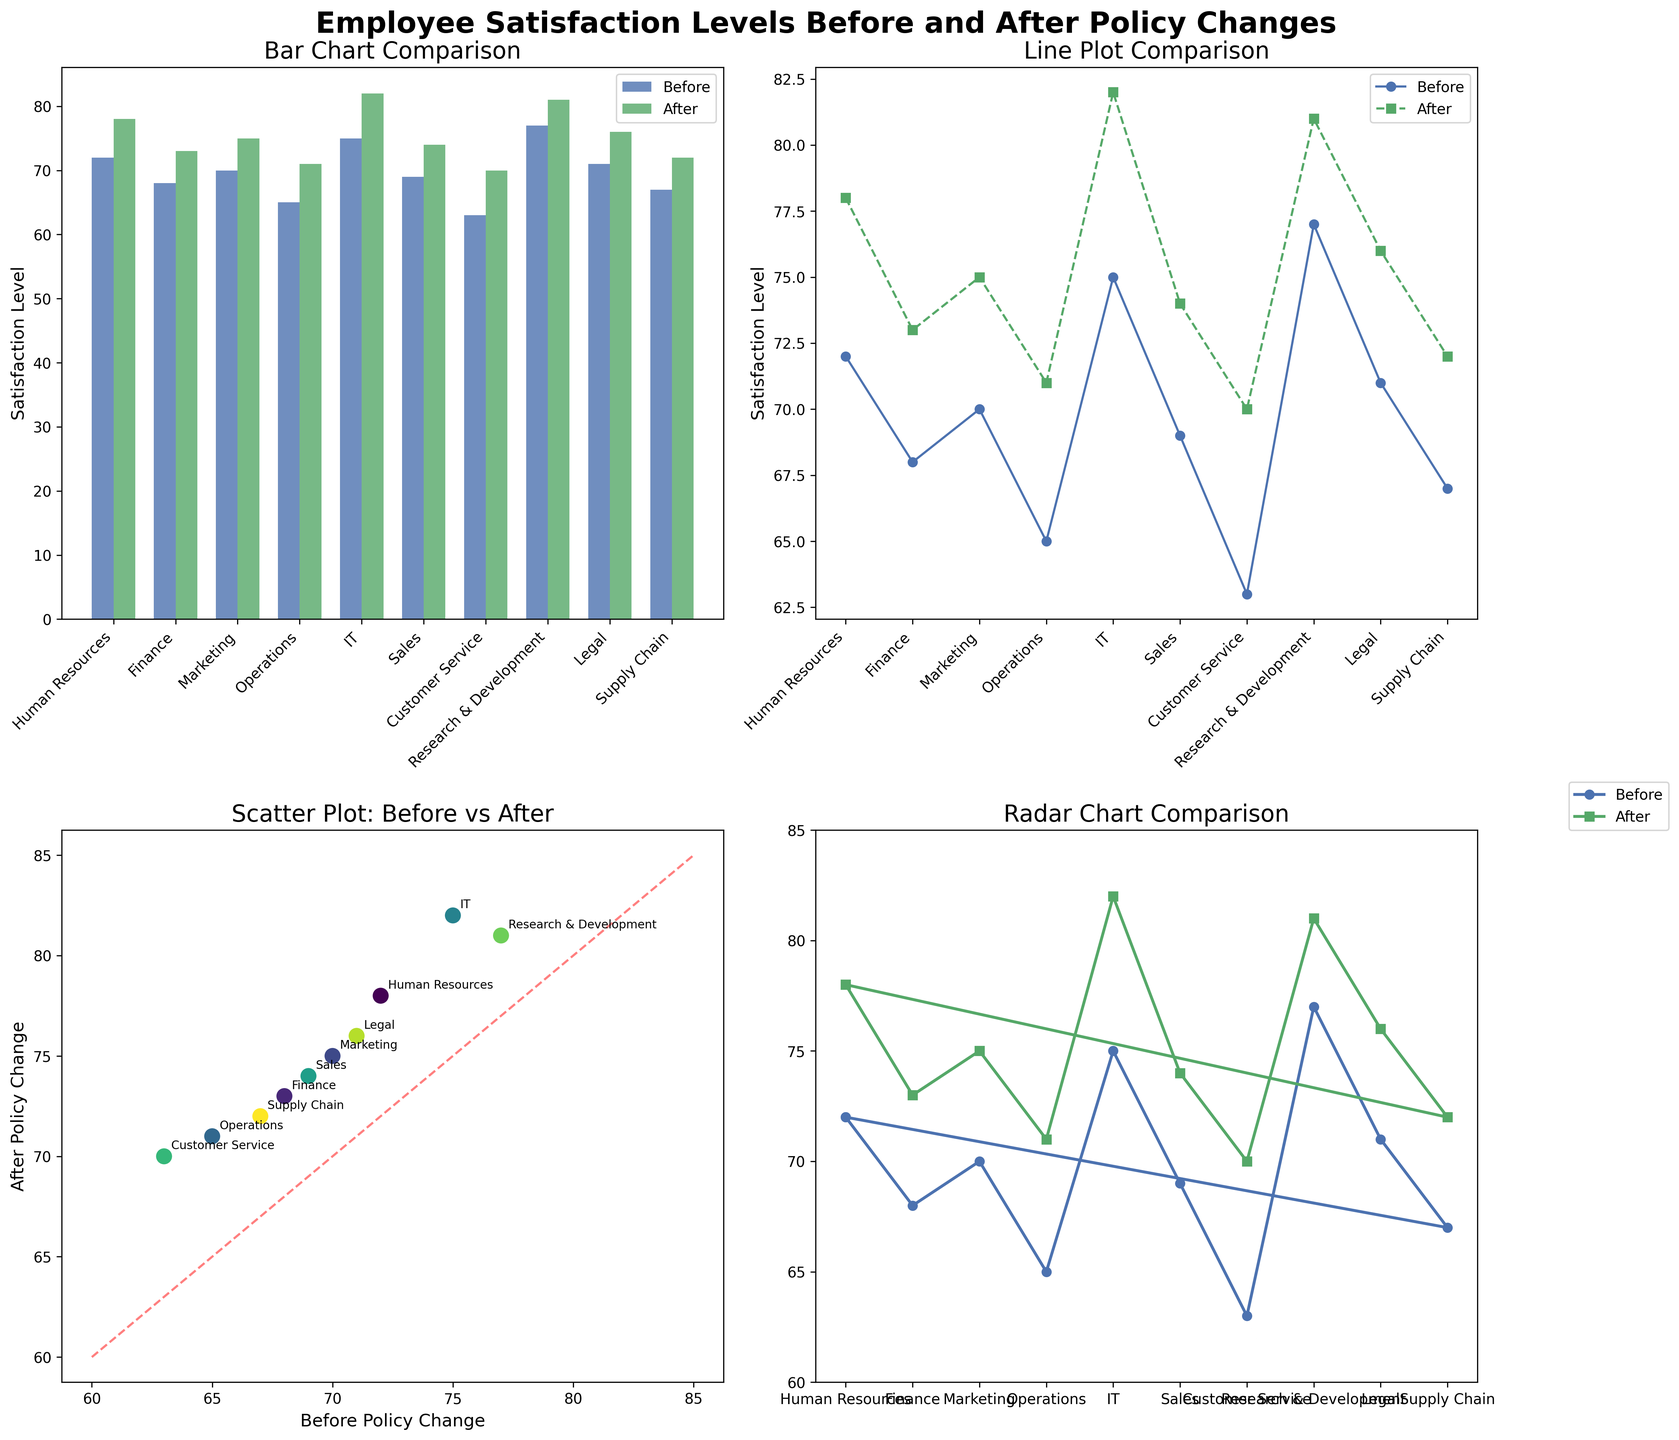What is the title of the entire figure? The title of the entire figure is positioned at the top and should summarize what the figure is about. It reads, "Employee Satisfaction Levels Before and After Policy Changes."
Answer: Employee Satisfaction Levels Before and After Policy Changes Which department shows the largest increase in satisfaction level? To find the largest increase in satisfaction, we need to calculate the difference between the satisfaction levels before and after the policy change for each department. The IT department has the largest increase (82 - 75 = 7).
Answer: IT In the bar chart, which department had the lowest satisfaction level before the policy change? Looking at the bar chart, the department with the shortest bar in the "Before" category had the lowest satisfaction level before the changes. This department is Customer Service.
Answer: Customer Service On the line plot, does the Marketing department show a higher satisfaction level before or after the policy change? On the line plot, we need to locate the point markers for the Marketing department. The after-policy change marker is higher than the before-policy change marker.
Answer: After In the scatter plot, which department corresponds to the point closer to the diagonal red line? The point close to the diagonal red line will have similar values for before and after. The Legal department's point is closest to this diagonal.
Answer: Legal For the radar chart, what is the satisfaction level of the Operations department after the policy change? On the radar chart, locate the Operations department along the axis and follow the "After" plot line to find the corresponding value. It shows the point at 71.
Answer: 71 Which type of plot shows individual departments annotated with their names? To answer this, look for the plot that has the names of the departments labeled. This is the scatter plot.
Answer: Scatter plot Based on the bar chart, which department has the closest satisfaction levels before and after the policy change? By comparing the heights of the bars in the bar chart, the Finance department has the closest satisfaction levels before (68) and after (73), a difference of 5.
Answer: Finance In the radar chart, how many departments have after-policy satisfaction levels above 75? Count the departments in the radar chart whose "After" plot line values are above 75. These are IT (82), R&D (81), and HR (78), making it 3 departments.
Answer: 3 